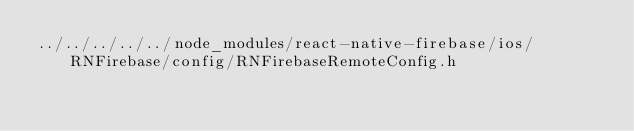<code> <loc_0><loc_0><loc_500><loc_500><_C_>../../../../../node_modules/react-native-firebase/ios/RNFirebase/config/RNFirebaseRemoteConfig.h</code> 